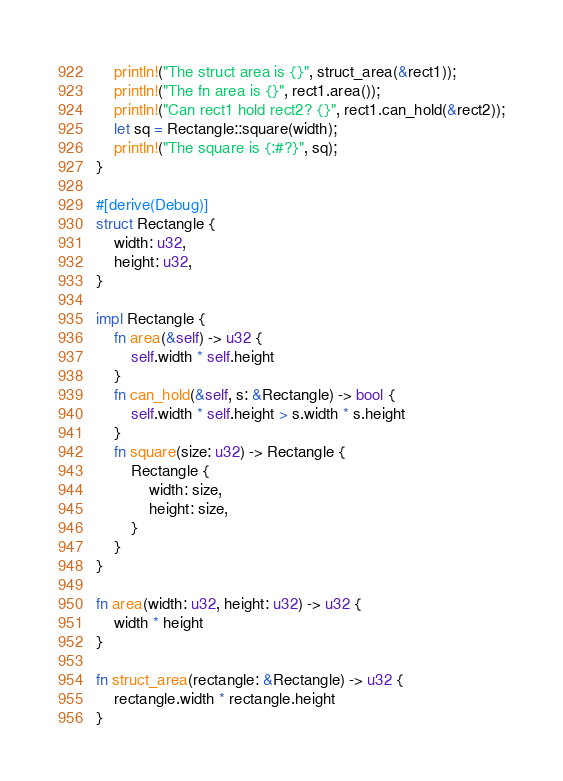Convert code to text. <code><loc_0><loc_0><loc_500><loc_500><_Rust_>	println!("The struct area is {}", struct_area(&rect1));
	println!("The fn area is {}", rect1.area());
	println!("Can rect1 hold rect2? {}", rect1.can_hold(&rect2));
	let sq = Rectangle::square(width);
	println!("The square is {:#?}", sq);
}

#[derive(Debug)]
struct Rectangle {
	width: u32,
	height: u32,
}

impl Rectangle {
	fn area(&self) -> u32 {
		self.width * self.height
	}
	fn can_hold(&self, s: &Rectangle) -> bool {
		self.width * self.height > s.width * s.height
	}
	fn square(size: u32) -> Rectangle {
		Rectangle {
			width: size,
			height: size,
		}
	}
}

fn area(width: u32, height: u32) -> u32 {
	width * height
}

fn struct_area(rectangle: &Rectangle) -> u32 {
	rectangle.width * rectangle.height
}
</code> 